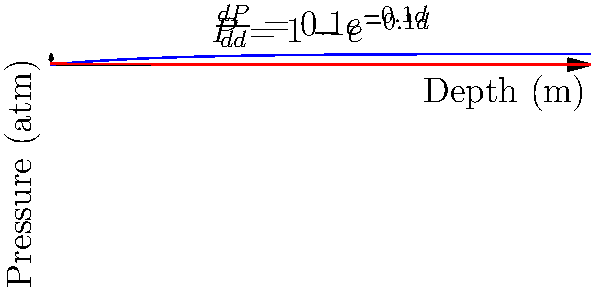As a scuba diver, you're interested in understanding how water pressure changes with depth. The graph shows the relationship between depth and pressure, as well as the rate of change of pressure with respect to depth. The pressure $P$ (in atmospheres) at a depth $d$ (in meters) is given by the function $P(d) = 1 - e^{-0.1d}$. At what depth is the rate of pressure change equal to 0.05 atmospheres per meter? To solve this problem, we'll follow these steps:

1) The rate of change of pressure with respect to depth is given by the derivative of $P(d)$:

   $$\frac{dP}{dd} = \frac{d}{dd}(1 - e^{-0.1d}) = 0.1e^{-0.1d}$$

2) We want to find the depth $d$ where this rate of change equals 0.05:

   $$0.1e^{-0.1d} = 0.05$$

3) Divide both sides by 0.1:

   $$e^{-0.1d} = 0.5$$

4) Take the natural logarithm of both sides:

   $$-0.1d = \ln(0.5)$$

5) Divide both sides by -0.1:

   $$d = -\frac{\ln(0.5)}{0.1}$$

6) Calculate the value:

   $$d = -\frac{\ln(0.5)}{0.1} \approx 6.93$$

Therefore, the rate of pressure change is equal to 0.05 atmospheres per meter at a depth of approximately 6.93 meters.
Answer: 6.93 meters 